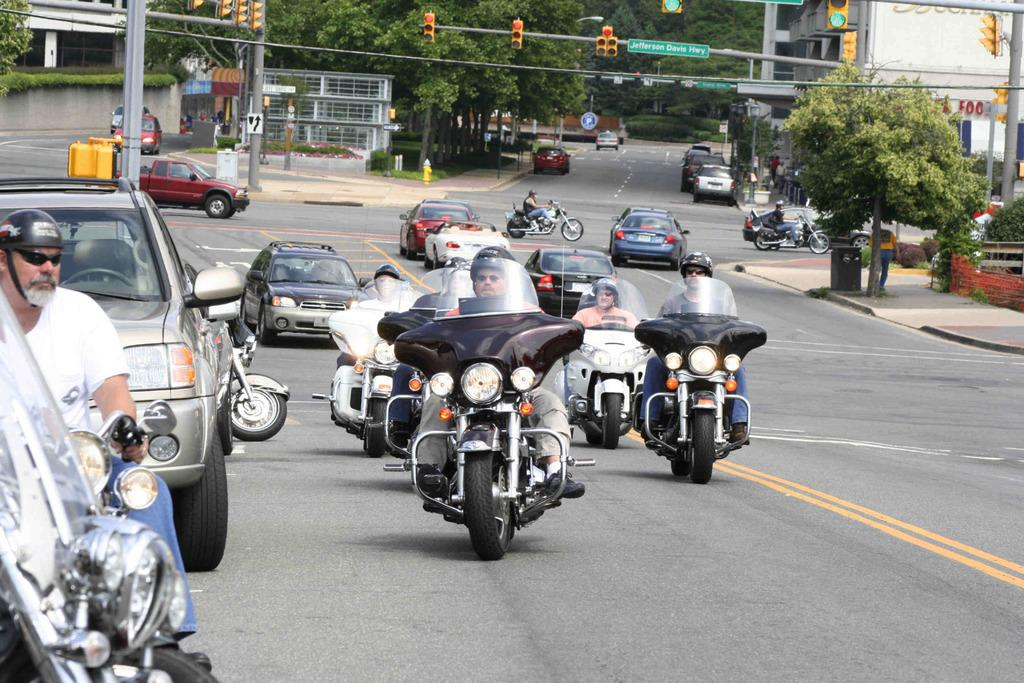What are the people doing in the image? There are people riding a motorbicycle and driving a car in the image. What can be seen in the image besides the vehicles? There is a signboard, a traffic signal, trees, and a building in the image. What type of juice is being exchanged between the people in the image? There is no juice or exchange of any kind depicted in the image. 